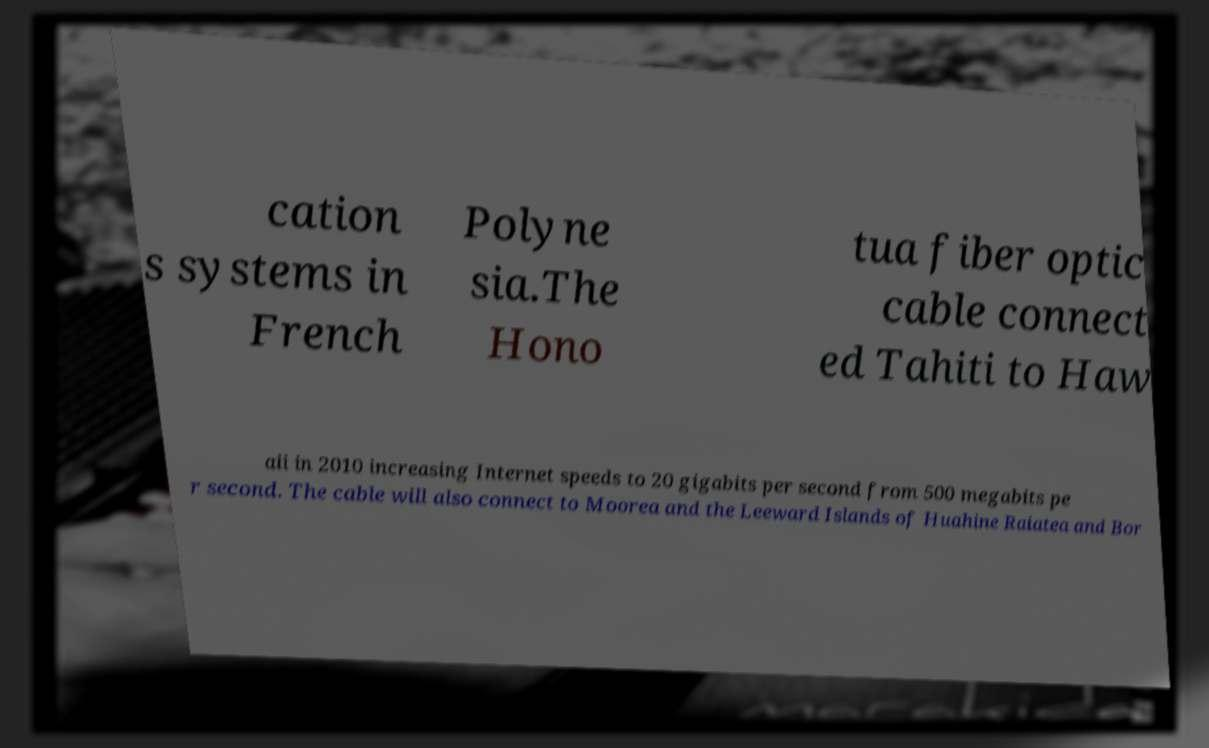Could you extract and type out the text from this image? cation s systems in French Polyne sia.The Hono tua fiber optic cable connect ed Tahiti to Haw aii in 2010 increasing Internet speeds to 20 gigabits per second from 500 megabits pe r second. The cable will also connect to Moorea and the Leeward Islands of Huahine Raiatea and Bor 